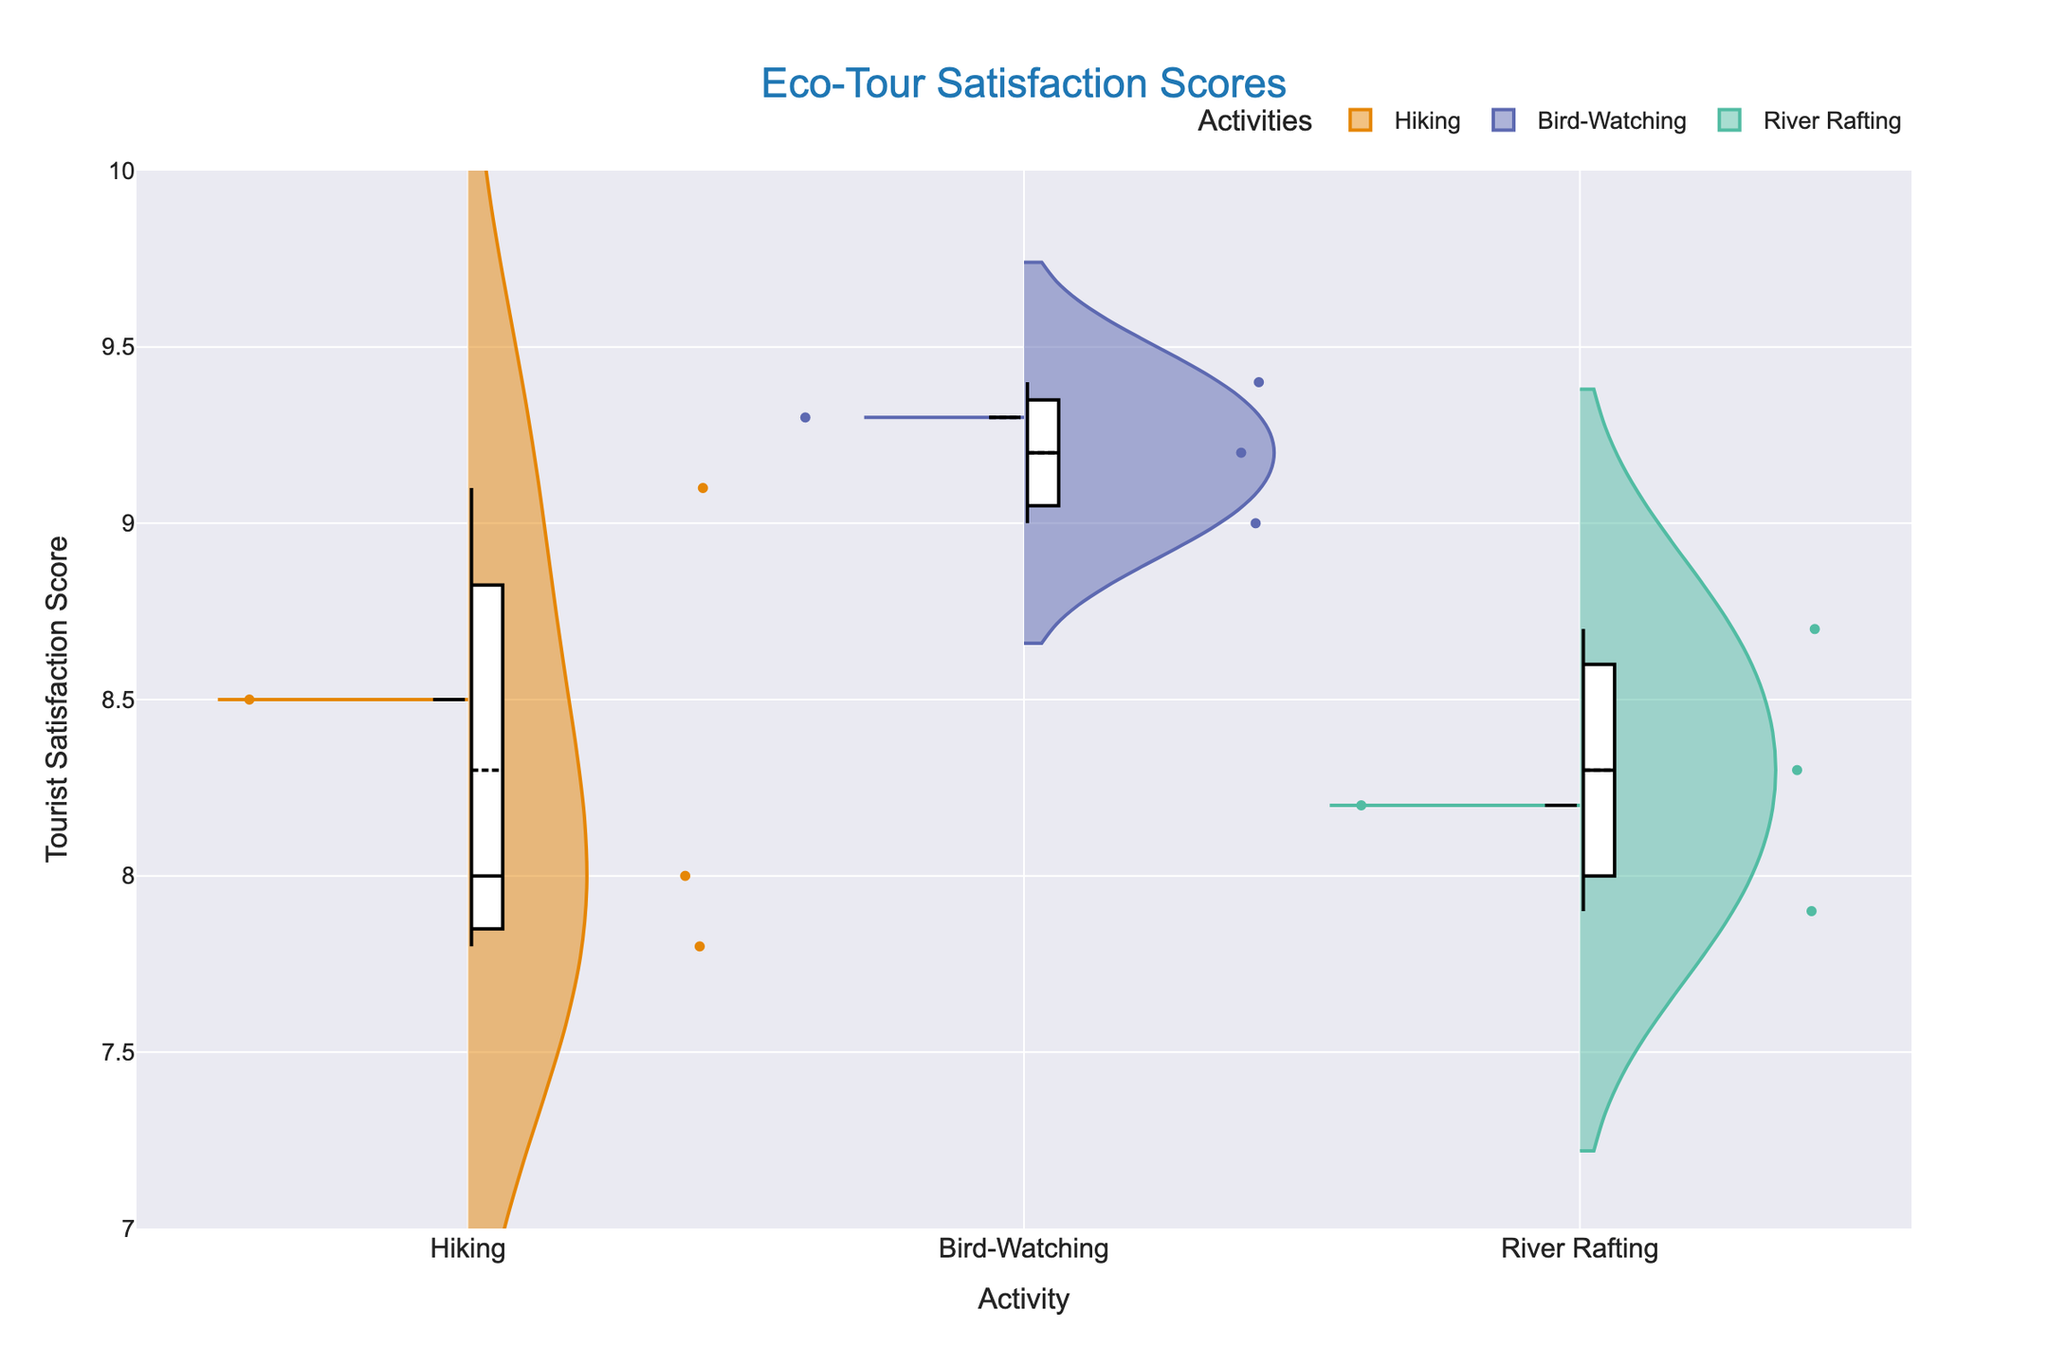What is the title of the figure? The title of the figure is shown at the top center in a larger font.
Answer: Eco-Tour Satisfaction Scores What is the activity with the highest mean tourist satisfaction score? Observing the mean lines, bird-watching shows the highest mean satisfaction scores among the activities.
Answer: Bird-Watching How do the satisfaction scores for hiking compare between Monteverde Cloud Forest Reserve and Yasuni National Park? For both reserves, look at the spread and mean lines of the satisfaction scores. Monteverde has higher mean scores and less variability than Yasuni.
Answer: Monteverde scores higher Which tour company in bird-watching at Corcovado National Park has a higher average satisfaction score? Look at the separate violins for Corcovado under bird-watching. Compare the positions of the mean lines within the shaded areas.
Answer: Rainforest Birding Which activity has the widest spread of tourist satisfaction scores? Assess the width of the violins across all activities. Hiking has the broadest range, indicating the most variability.
Answer: Hiking What is the approximate range of tourist satisfaction scores for river rafting? Check the lowest and highest points within the violin charts for river rafting.
Answer: 7.9 to 8.7 Are the satisfaction scores for River Rafting in Pacaya-Samiria consistently lower or higher than in Taman Negara? Compare the violins for river rafting in the two locations; look for mean lines and score spreads.
Answer: Generally lower in Pacaya-Samiria Which bird-watching tour company has the highest individual satisfaction score? Look for the highest dots within the bird-watching violins.
Answer: Rainforest Birding Do any activities have overlapping satisfaction scores, and if so, which ones? Look at the overlap of the violin plots; the widest overlapping occurs between hiking and river rafting scores.
Answer: Hiking and River Rafting Is there a significant difference in satisfaction scores within the same activity offered by different companies? Compare the width and mean lines between left and right sides for each activity. Particularly for hiking, significant differences are noted within the same activity.
Answer: Yes, especially for hiking 